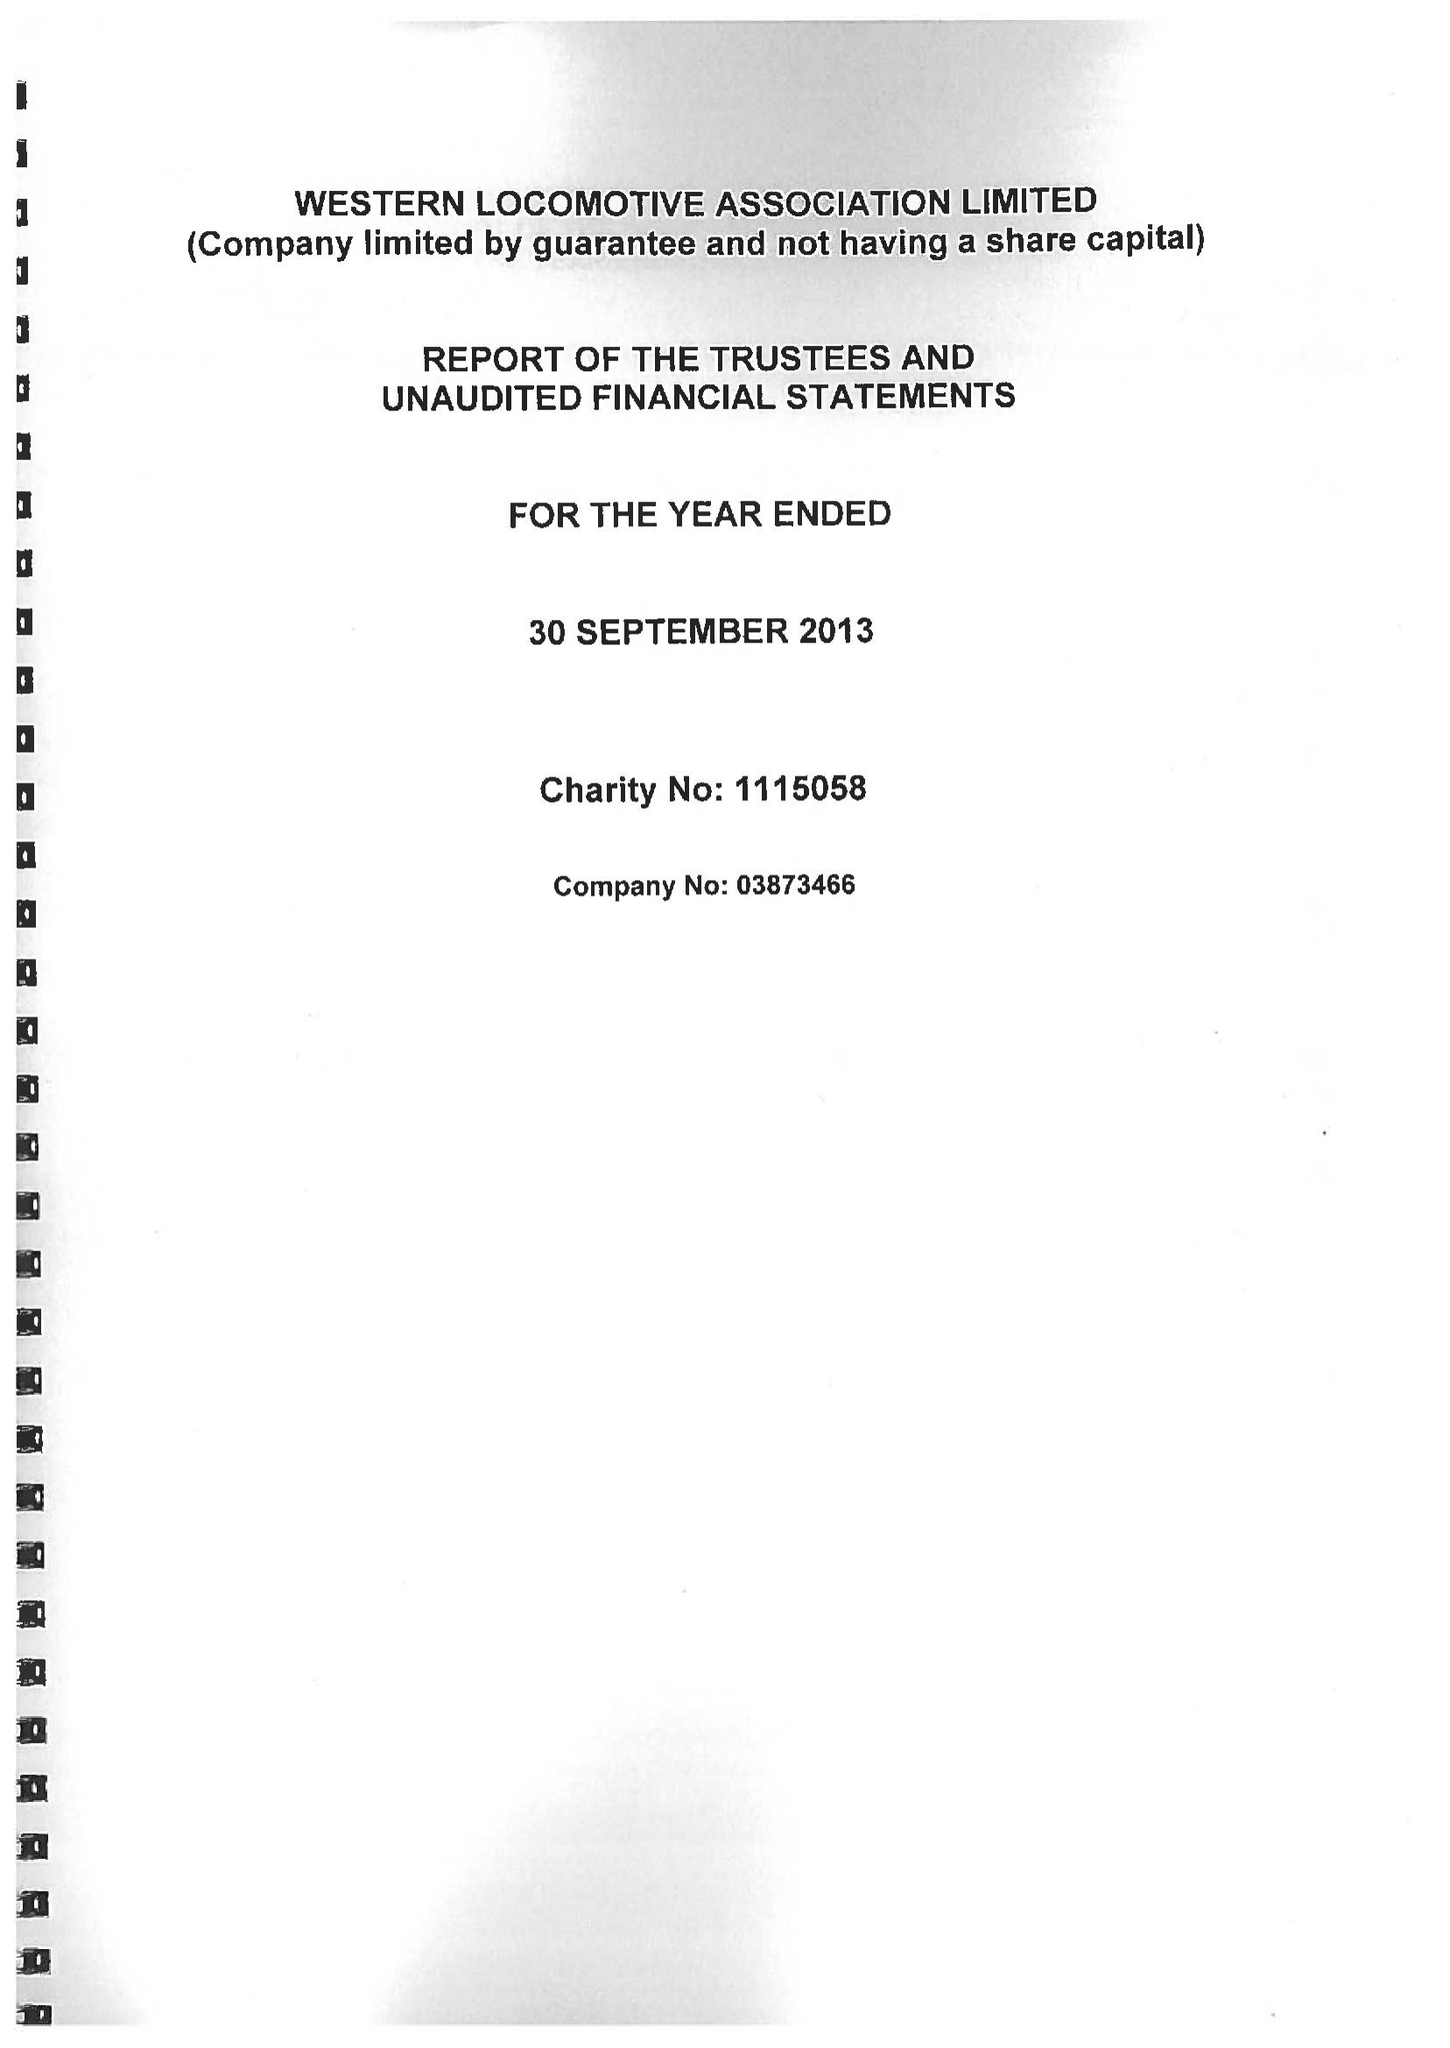What is the value for the address__street_line?
Answer the question using a single word or phrase. 27 COMPTON ROAD 